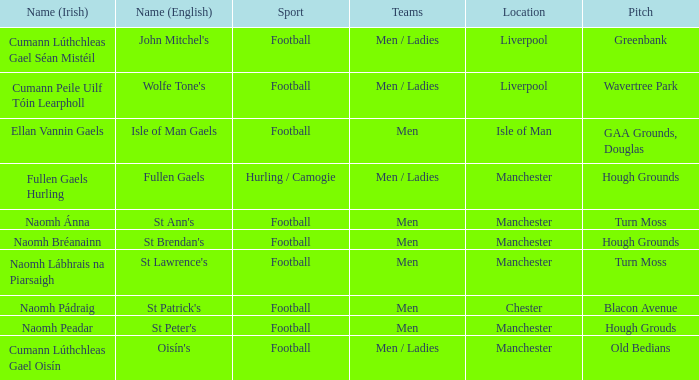What is the english term for the spot in chester? St Patrick's. 